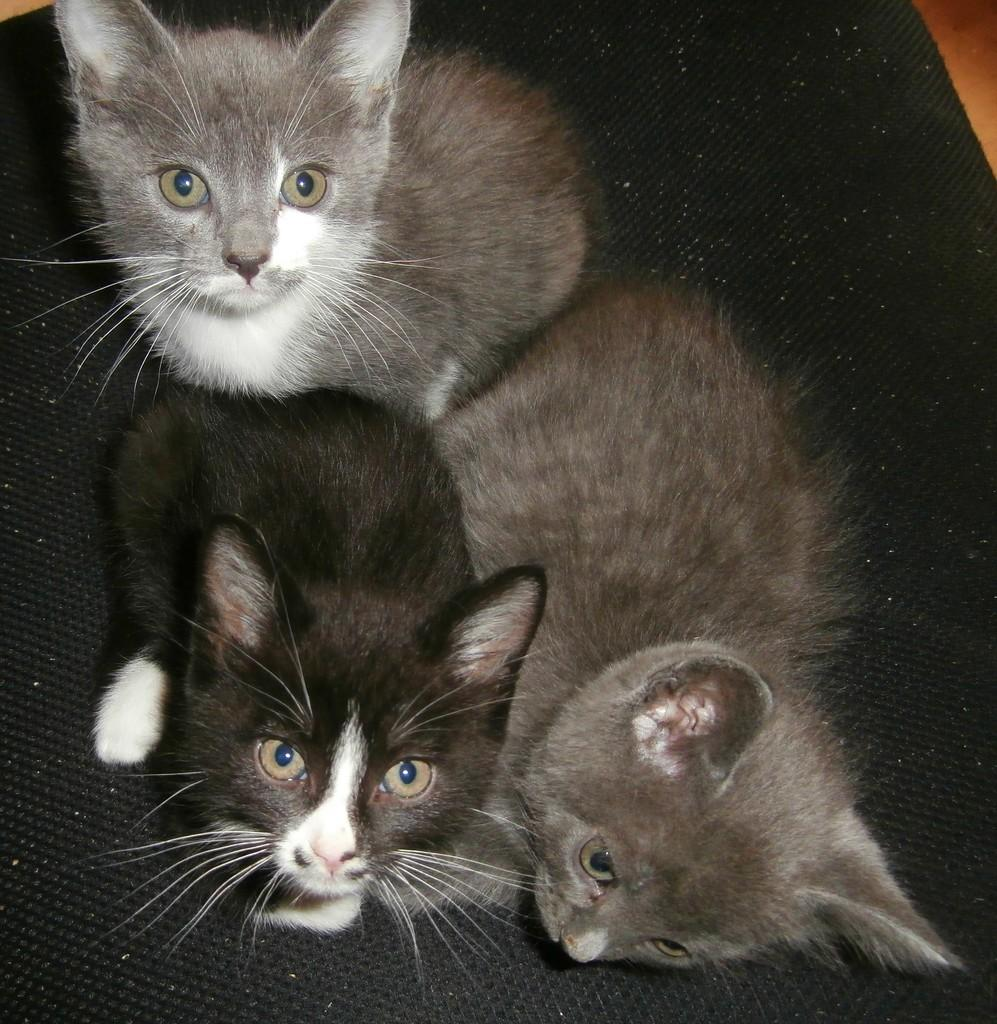How many cats are present in the image? There are three cats in the image. What colors are the cats? The cats are black and grey in color. What is located at the bottom of the image? There is a mat at the bottom of the image. What type of instrument is the cat playing in the image? There is no instrument present in the image, and the cats are not playing any instruments. 